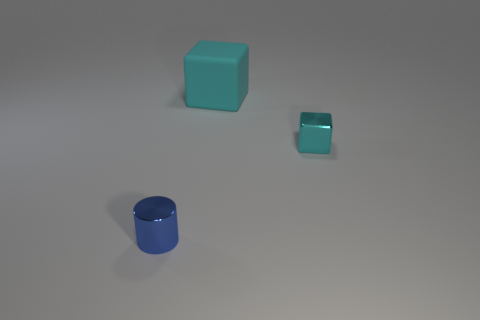Is there any other thing that is made of the same material as the big thing?
Your response must be concise. No. What shape is the small shiny object in front of the tiny thing that is on the right side of the big cube?
Your answer should be compact. Cylinder. What is the size of the metallic thing that is the same shape as the large cyan matte thing?
Make the answer very short. Small. Are there any other things that have the same size as the shiny cylinder?
Provide a succinct answer. Yes. There is a object that is on the left side of the cyan rubber cube; what color is it?
Offer a very short reply. Blue. What material is the cyan object in front of the cube to the left of the tiny thing right of the big cyan rubber block?
Your answer should be compact. Metal. There is a cyan block that is left of the small thing behind the small blue thing; what size is it?
Offer a very short reply. Large. What number of large objects have the same color as the tiny metallic block?
Provide a short and direct response. 1. Do the metal cylinder and the rubber block have the same size?
Provide a succinct answer. No. What is the tiny blue cylinder made of?
Give a very brief answer. Metal. 